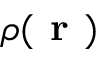<formula> <loc_0><loc_0><loc_500><loc_500>\rho ( r )</formula> 